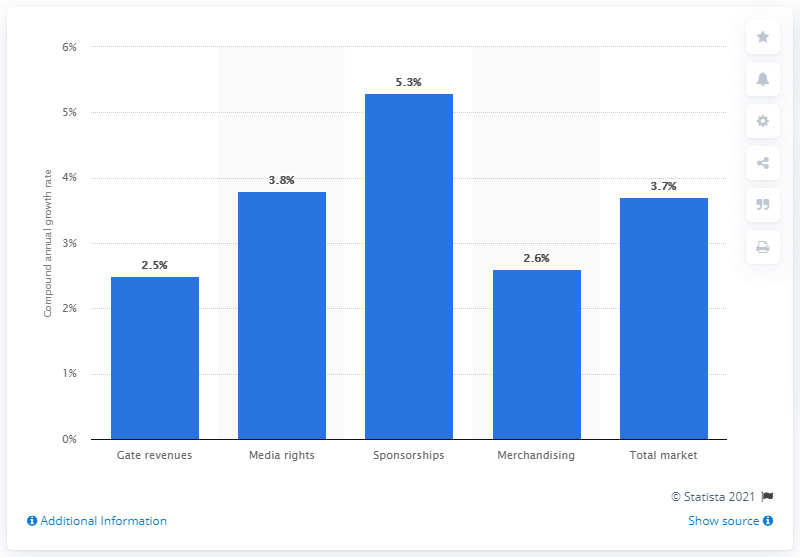List a handful of essential elements in this visual. According to projections, media rights revenue is expected to increase by 3.8% from 2011 to 2015. 